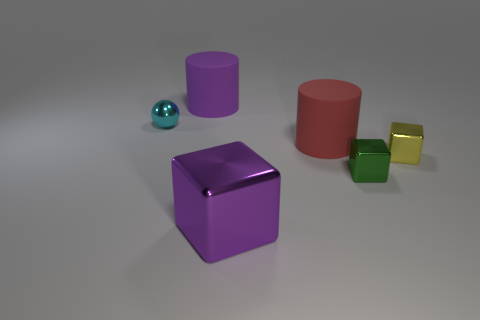Subtract all small metal cubes. How many cubes are left? 1 Add 4 small yellow objects. How many objects exist? 10 Subtract all balls. How many objects are left? 5 Subtract all large yellow matte things. Subtract all large red rubber objects. How many objects are left? 5 Add 3 yellow metal blocks. How many yellow metal blocks are left? 4 Add 2 large gray rubber balls. How many large gray rubber balls exist? 2 Subtract 0 yellow cylinders. How many objects are left? 6 Subtract all red balls. Subtract all brown cylinders. How many balls are left? 1 